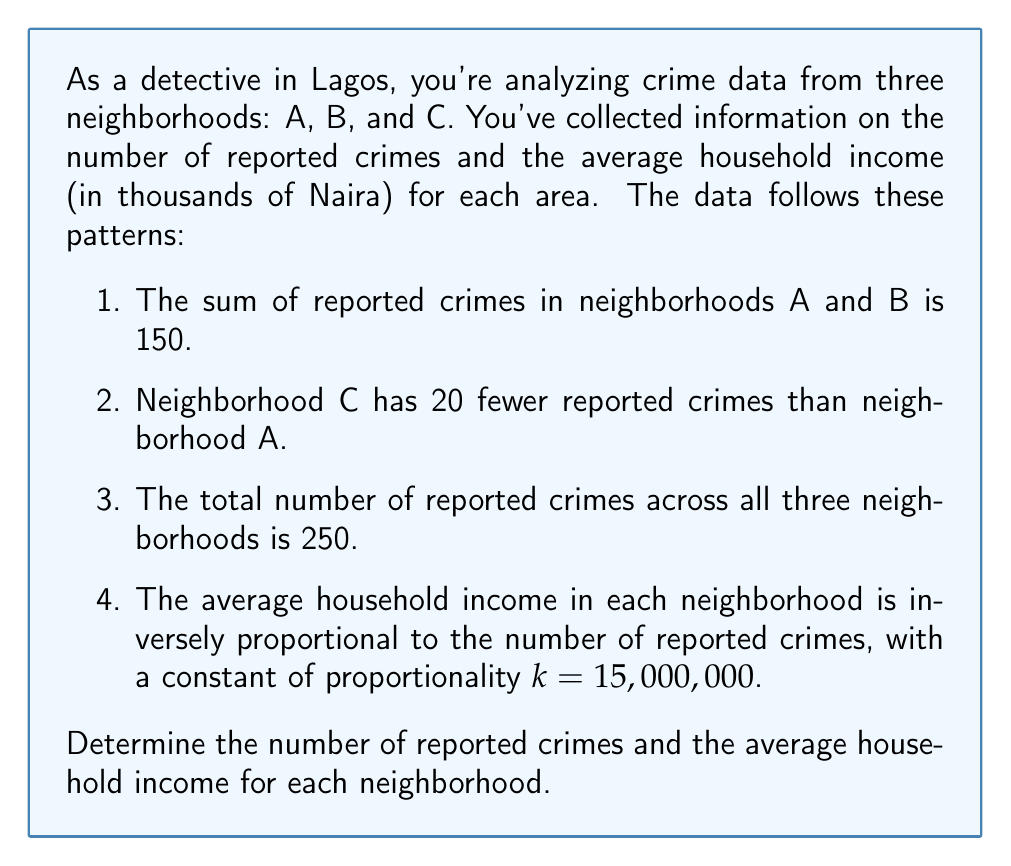Can you answer this question? Let's approach this step-by-step:

1) Let $x$, $y$, and $z$ represent the number of reported crimes in neighborhoods A, B, and C respectively.

2) From the given information, we can form these equations:
   $$x + y = 150$$ (Equation 1)
   $$z = x - 20$$ (Equation 2)
   $$x + y + z = 250$$ (Equation 3)

3) Substituting Equation 2 into Equation 3:
   $$x + y + (x - 20) = 250$$
   $$2x + y = 270$$ (Equation 4)

4) Now we have a system of two equations with two unknowns:
   $$x + y = 150$$ (Equation 1)
   $$2x + y = 270$$ (Equation 4)

5) Subtracting Equation 1 from Equation 4:
   $$x = 120$$

6) Substituting this back into Equation 1:
   $$120 + y = 150$$
   $$y = 30$$

7) Using Equation 2 to find $z$:
   $$z = 120 - 20 = 100$$

8) Now for the average household income. Let $I_A$, $I_B$, and $I_C$ represent the average household income for neighborhoods A, B, and C respectively. Using the inverse proportionality relationship:

   $$I_A = \frac{k}{x} = \frac{15,000,000}{120} = 125,000$$
   $$I_B = \frac{k}{y} = \frac{15,000,000}{30} = 500,000$$
   $$I_C = \frac{k}{z} = \frac{15,000,000}{100} = 150,000$$

Thus, we have solved for both the number of reported crimes and the average household income for each neighborhood.
Answer: Neighborhood A: 120 reported crimes, 125,000 Naira average household income
Neighborhood B: 30 reported crimes, 500,000 Naira average household income
Neighborhood C: 100 reported crimes, 150,000 Naira average household income 